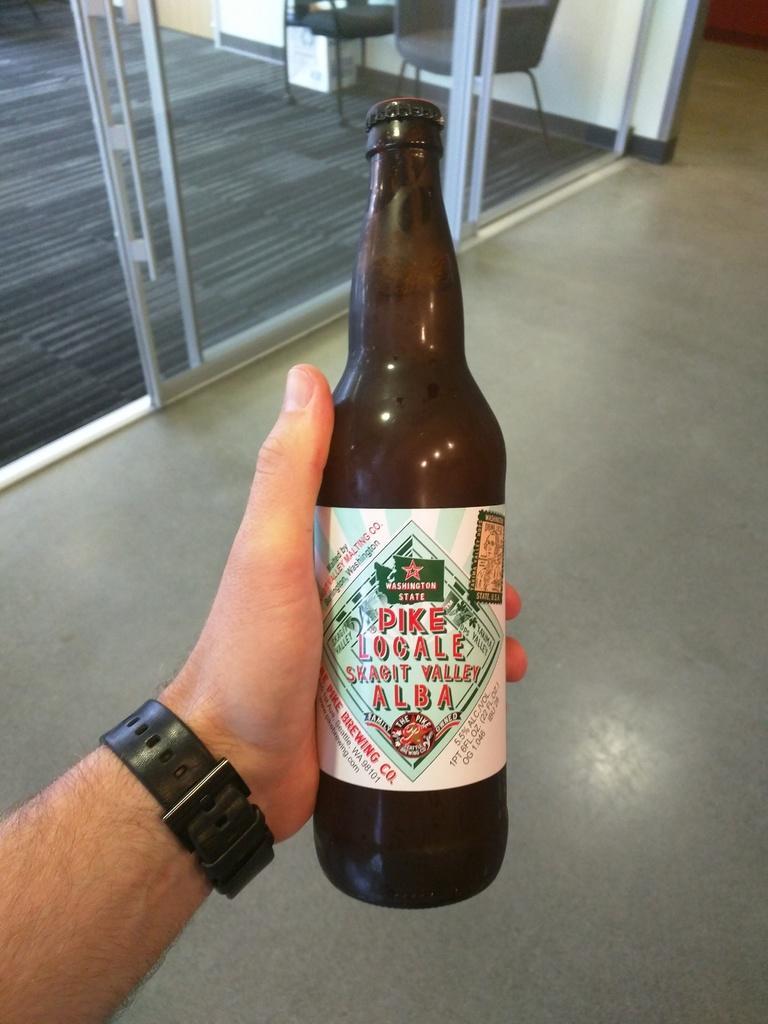Can you describe this image briefly? This image consists of a bottle. It is in brown color. A person is holding that. There is a door at the top. There is a chair at the top. 